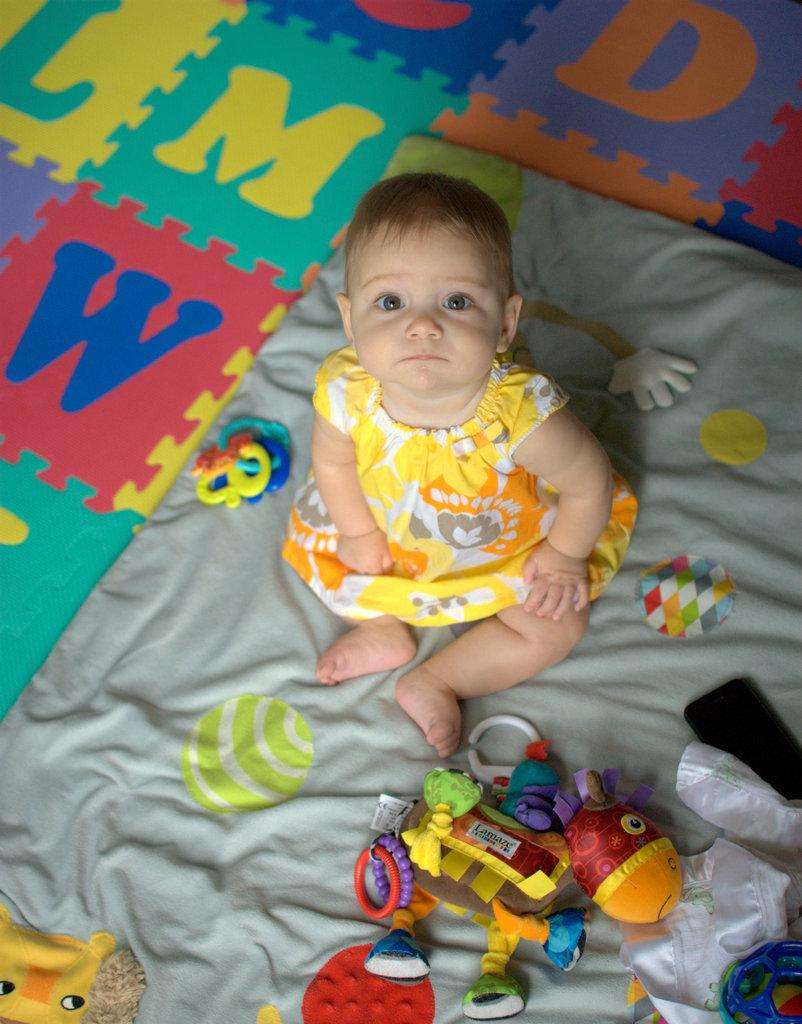What is the main subject in the foreground of the image? There is a kid sitting on a bed in the foreground of the image. What else can be seen on the bed? There are many toys on the bed. What type of flooring is visible at the top of the image? The top of the image has a letters grid flooring. Can you see a gun in the image? No, there is no gun present in the image. Are there any men visible in the image? No, the image only features a kid sitting on a bed and toys on the bed. 